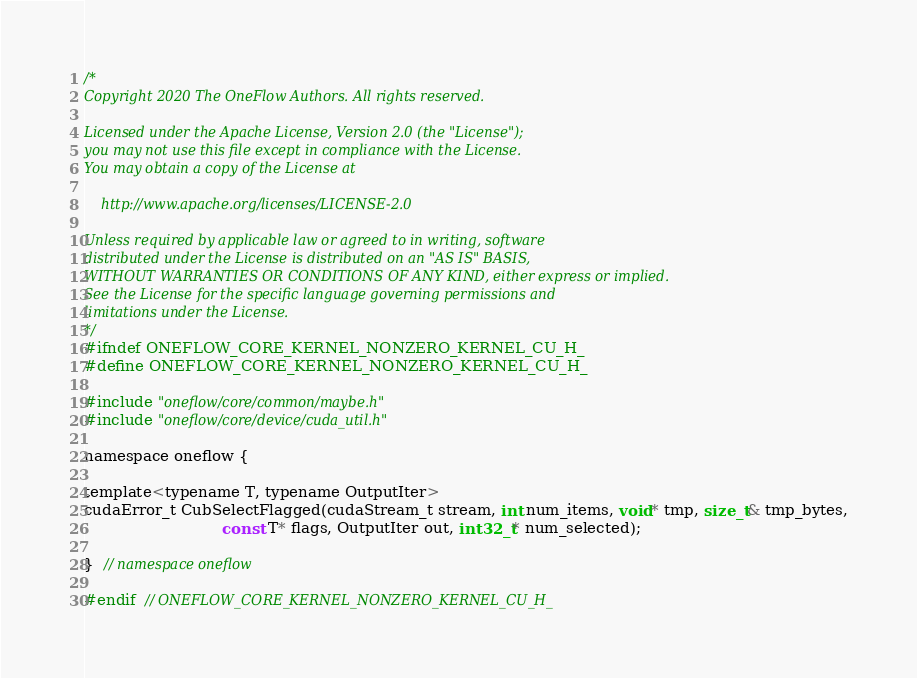<code> <loc_0><loc_0><loc_500><loc_500><_Cuda_>/*
Copyright 2020 The OneFlow Authors. All rights reserved.

Licensed under the Apache License, Version 2.0 (the "License");
you may not use this file except in compliance with the License.
You may obtain a copy of the License at

    http://www.apache.org/licenses/LICENSE-2.0

Unless required by applicable law or agreed to in writing, software
distributed under the License is distributed on an "AS IS" BASIS,
WITHOUT WARRANTIES OR CONDITIONS OF ANY KIND, either express or implied.
See the License for the specific language governing permissions and
limitations under the License.
*/
#ifndef ONEFLOW_CORE_KERNEL_NONZERO_KERNEL_CU_H_
#define ONEFLOW_CORE_KERNEL_NONZERO_KERNEL_CU_H_

#include "oneflow/core/common/maybe.h"
#include "oneflow/core/device/cuda_util.h"

namespace oneflow {

template<typename T, typename OutputIter>
cudaError_t CubSelectFlagged(cudaStream_t stream, int num_items, void* tmp, size_t& tmp_bytes,
                             const T* flags, OutputIter out, int32_t* num_selected);

}  // namespace oneflow

#endif  // ONEFLOW_CORE_KERNEL_NONZERO_KERNEL_CU_H_
</code> 